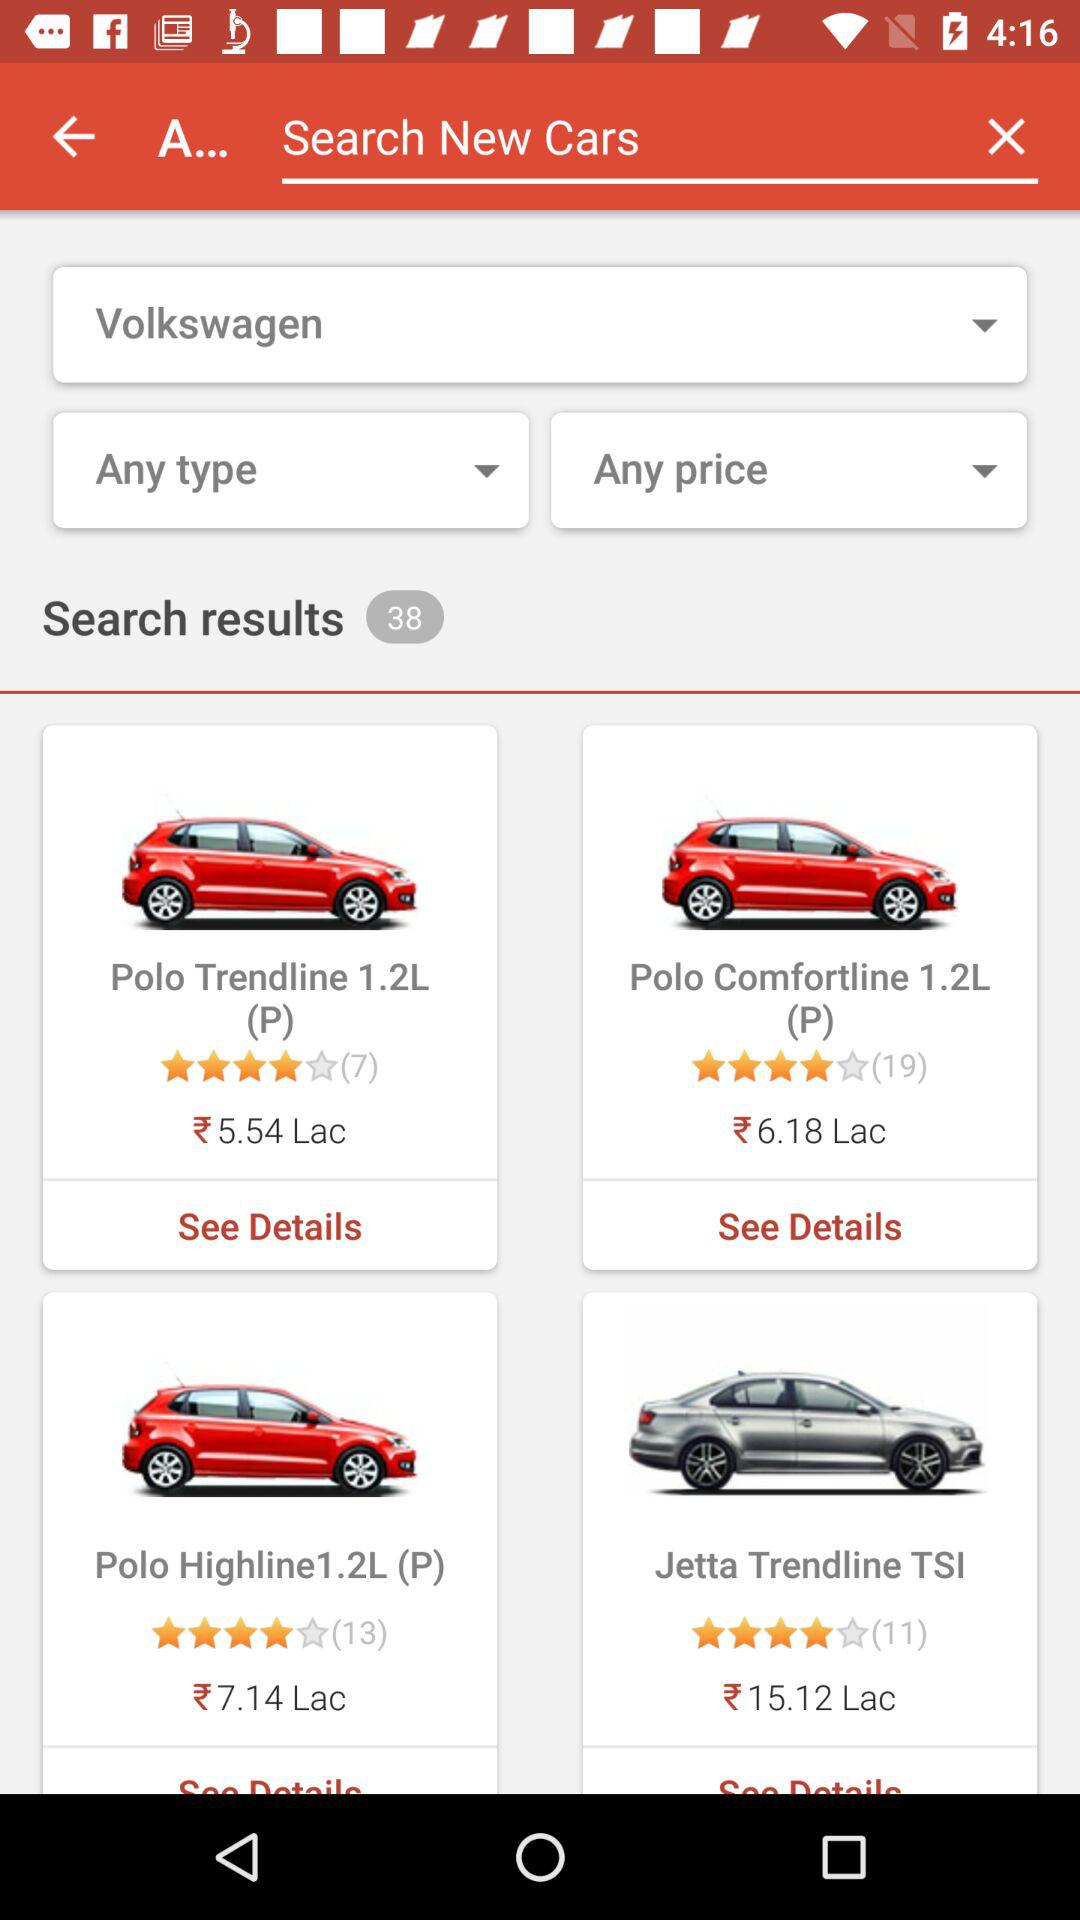Which car's price is 7.14 lacs? The car is "Polo Highline1.2L (P)". 